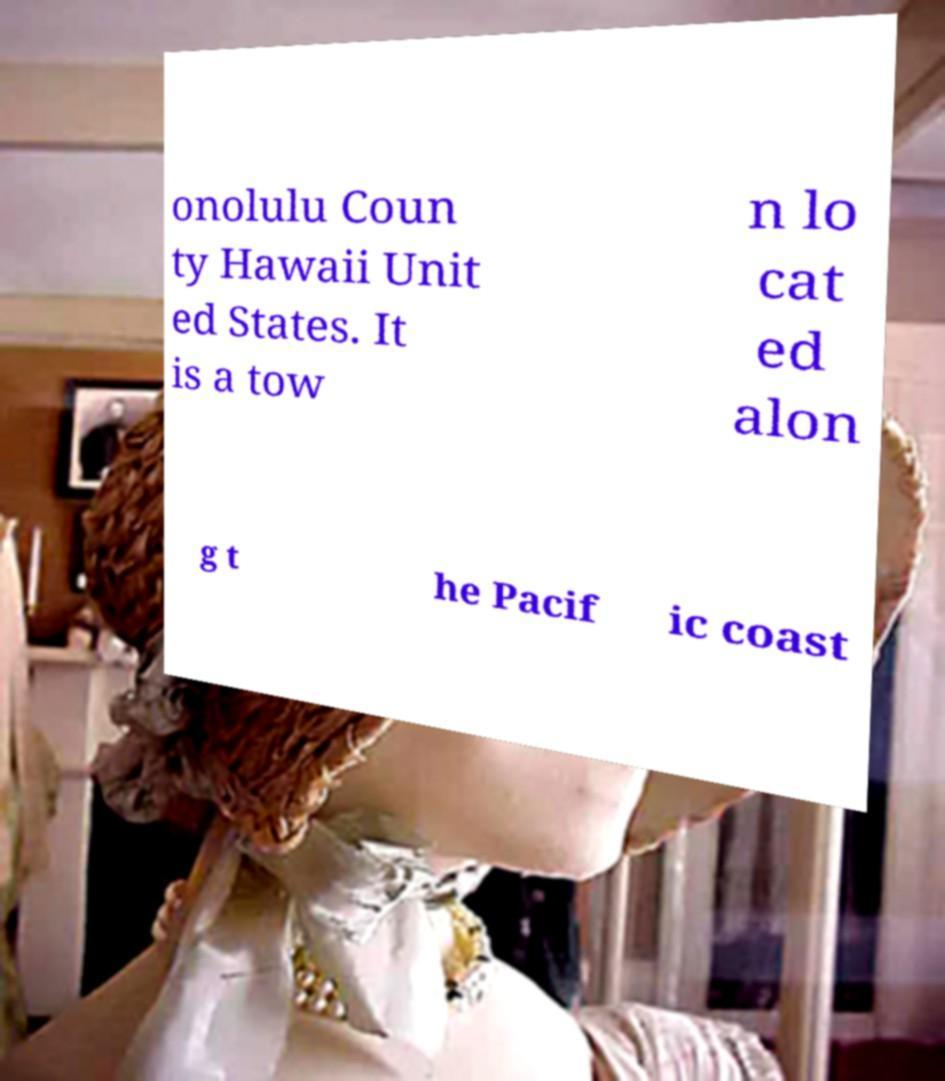Could you extract and type out the text from this image? onolulu Coun ty Hawaii Unit ed States. It is a tow n lo cat ed alon g t he Pacif ic coast 